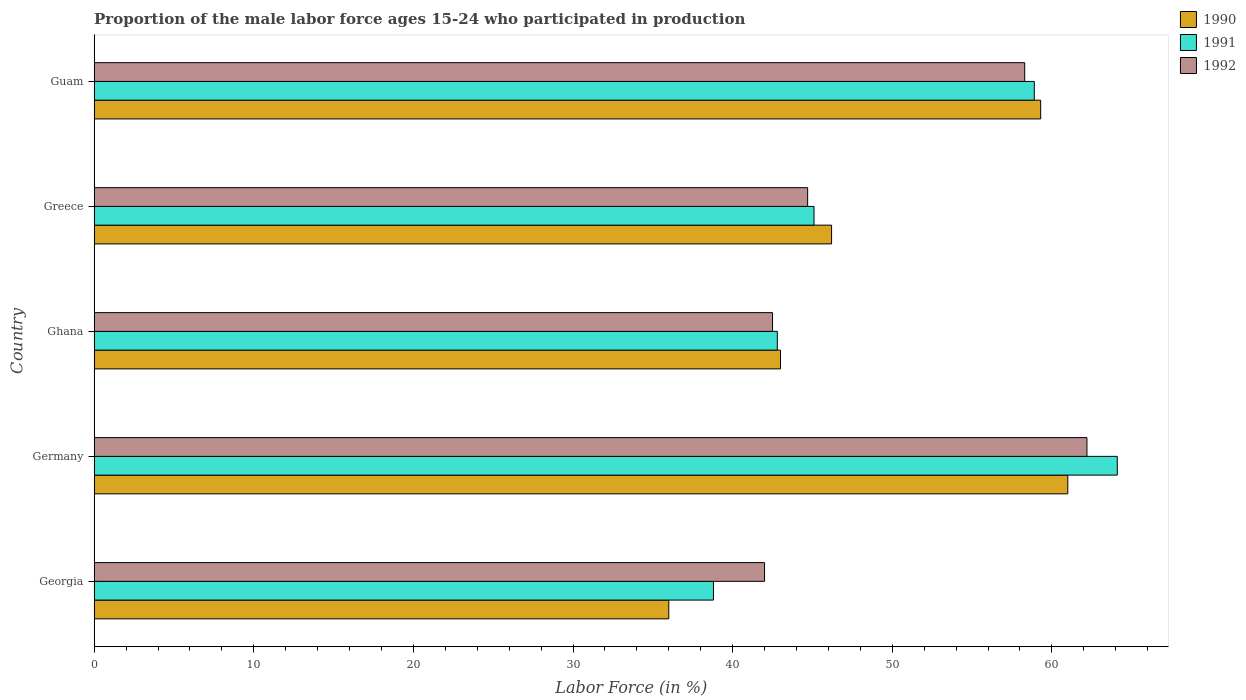How many different coloured bars are there?
Provide a short and direct response. 3. How many groups of bars are there?
Provide a succinct answer. 5. How many bars are there on the 2nd tick from the top?
Ensure brevity in your answer.  3. How many bars are there on the 1st tick from the bottom?
Keep it short and to the point. 3. What is the proportion of the male labor force who participated in production in 1990 in Ghana?
Offer a very short reply. 43. Across all countries, what is the maximum proportion of the male labor force who participated in production in 1992?
Keep it short and to the point. 62.2. Across all countries, what is the minimum proportion of the male labor force who participated in production in 1991?
Keep it short and to the point. 38.8. In which country was the proportion of the male labor force who participated in production in 1991 maximum?
Give a very brief answer. Germany. In which country was the proportion of the male labor force who participated in production in 1990 minimum?
Keep it short and to the point. Georgia. What is the total proportion of the male labor force who participated in production in 1990 in the graph?
Give a very brief answer. 245.5. What is the difference between the proportion of the male labor force who participated in production in 1991 in Georgia and that in Germany?
Ensure brevity in your answer.  -25.3. What is the difference between the proportion of the male labor force who participated in production in 1991 in Greece and the proportion of the male labor force who participated in production in 1990 in Georgia?
Offer a terse response. 9.1. What is the average proportion of the male labor force who participated in production in 1991 per country?
Provide a succinct answer. 49.94. What is the difference between the proportion of the male labor force who participated in production in 1991 and proportion of the male labor force who participated in production in 1990 in Ghana?
Give a very brief answer. -0.2. What is the ratio of the proportion of the male labor force who participated in production in 1991 in Georgia to that in Ghana?
Provide a succinct answer. 0.91. Is the proportion of the male labor force who participated in production in 1991 in Georgia less than that in Greece?
Provide a short and direct response. Yes. What is the difference between the highest and the second highest proportion of the male labor force who participated in production in 1990?
Offer a terse response. 1.7. What does the 3rd bar from the top in Greece represents?
Your answer should be very brief. 1990. What does the 1st bar from the bottom in Ghana represents?
Keep it short and to the point. 1990. Is it the case that in every country, the sum of the proportion of the male labor force who participated in production in 1991 and proportion of the male labor force who participated in production in 1992 is greater than the proportion of the male labor force who participated in production in 1990?
Your response must be concise. Yes. Are all the bars in the graph horizontal?
Your response must be concise. Yes. What is the difference between two consecutive major ticks on the X-axis?
Keep it short and to the point. 10. How are the legend labels stacked?
Keep it short and to the point. Vertical. What is the title of the graph?
Your answer should be compact. Proportion of the male labor force ages 15-24 who participated in production. Does "1992" appear as one of the legend labels in the graph?
Provide a succinct answer. Yes. What is the Labor Force (in %) in 1990 in Georgia?
Make the answer very short. 36. What is the Labor Force (in %) of 1991 in Georgia?
Ensure brevity in your answer.  38.8. What is the Labor Force (in %) in 1992 in Georgia?
Provide a succinct answer. 42. What is the Labor Force (in %) in 1991 in Germany?
Your answer should be compact. 64.1. What is the Labor Force (in %) of 1992 in Germany?
Your answer should be compact. 62.2. What is the Labor Force (in %) in 1991 in Ghana?
Provide a short and direct response. 42.8. What is the Labor Force (in %) in 1992 in Ghana?
Keep it short and to the point. 42.5. What is the Labor Force (in %) of 1990 in Greece?
Provide a succinct answer. 46.2. What is the Labor Force (in %) in 1991 in Greece?
Provide a succinct answer. 45.1. What is the Labor Force (in %) of 1992 in Greece?
Provide a short and direct response. 44.7. What is the Labor Force (in %) in 1990 in Guam?
Provide a succinct answer. 59.3. What is the Labor Force (in %) of 1991 in Guam?
Keep it short and to the point. 58.9. What is the Labor Force (in %) of 1992 in Guam?
Make the answer very short. 58.3. Across all countries, what is the maximum Labor Force (in %) in 1990?
Give a very brief answer. 61. Across all countries, what is the maximum Labor Force (in %) in 1991?
Provide a short and direct response. 64.1. Across all countries, what is the maximum Labor Force (in %) of 1992?
Keep it short and to the point. 62.2. Across all countries, what is the minimum Labor Force (in %) of 1990?
Give a very brief answer. 36. Across all countries, what is the minimum Labor Force (in %) in 1991?
Make the answer very short. 38.8. Across all countries, what is the minimum Labor Force (in %) of 1992?
Your response must be concise. 42. What is the total Labor Force (in %) of 1990 in the graph?
Your answer should be compact. 245.5. What is the total Labor Force (in %) in 1991 in the graph?
Your answer should be very brief. 249.7. What is the total Labor Force (in %) in 1992 in the graph?
Keep it short and to the point. 249.7. What is the difference between the Labor Force (in %) in 1990 in Georgia and that in Germany?
Provide a succinct answer. -25. What is the difference between the Labor Force (in %) of 1991 in Georgia and that in Germany?
Your response must be concise. -25.3. What is the difference between the Labor Force (in %) in 1992 in Georgia and that in Germany?
Offer a very short reply. -20.2. What is the difference between the Labor Force (in %) of 1991 in Georgia and that in Ghana?
Provide a succinct answer. -4. What is the difference between the Labor Force (in %) of 1992 in Georgia and that in Ghana?
Your answer should be very brief. -0.5. What is the difference between the Labor Force (in %) of 1992 in Georgia and that in Greece?
Provide a short and direct response. -2.7. What is the difference between the Labor Force (in %) in 1990 in Georgia and that in Guam?
Give a very brief answer. -23.3. What is the difference between the Labor Force (in %) in 1991 in Georgia and that in Guam?
Provide a succinct answer. -20.1. What is the difference between the Labor Force (in %) in 1992 in Georgia and that in Guam?
Your response must be concise. -16.3. What is the difference between the Labor Force (in %) of 1991 in Germany and that in Ghana?
Offer a terse response. 21.3. What is the difference between the Labor Force (in %) in 1992 in Germany and that in Greece?
Provide a succinct answer. 17.5. What is the difference between the Labor Force (in %) of 1990 in Germany and that in Guam?
Offer a very short reply. 1.7. What is the difference between the Labor Force (in %) of 1991 in Germany and that in Guam?
Your response must be concise. 5.2. What is the difference between the Labor Force (in %) in 1991 in Ghana and that in Greece?
Your answer should be compact. -2.3. What is the difference between the Labor Force (in %) of 1992 in Ghana and that in Greece?
Your answer should be compact. -2.2. What is the difference between the Labor Force (in %) in 1990 in Ghana and that in Guam?
Provide a succinct answer. -16.3. What is the difference between the Labor Force (in %) of 1991 in Ghana and that in Guam?
Make the answer very short. -16.1. What is the difference between the Labor Force (in %) in 1992 in Ghana and that in Guam?
Keep it short and to the point. -15.8. What is the difference between the Labor Force (in %) of 1991 in Greece and that in Guam?
Keep it short and to the point. -13.8. What is the difference between the Labor Force (in %) of 1990 in Georgia and the Labor Force (in %) of 1991 in Germany?
Your answer should be compact. -28.1. What is the difference between the Labor Force (in %) in 1990 in Georgia and the Labor Force (in %) in 1992 in Germany?
Ensure brevity in your answer.  -26.2. What is the difference between the Labor Force (in %) in 1991 in Georgia and the Labor Force (in %) in 1992 in Germany?
Provide a short and direct response. -23.4. What is the difference between the Labor Force (in %) of 1990 in Georgia and the Labor Force (in %) of 1991 in Greece?
Provide a succinct answer. -9.1. What is the difference between the Labor Force (in %) of 1990 in Georgia and the Labor Force (in %) of 1992 in Greece?
Your response must be concise. -8.7. What is the difference between the Labor Force (in %) of 1990 in Georgia and the Labor Force (in %) of 1991 in Guam?
Ensure brevity in your answer.  -22.9. What is the difference between the Labor Force (in %) of 1990 in Georgia and the Labor Force (in %) of 1992 in Guam?
Make the answer very short. -22.3. What is the difference between the Labor Force (in %) in 1991 in Georgia and the Labor Force (in %) in 1992 in Guam?
Provide a succinct answer. -19.5. What is the difference between the Labor Force (in %) of 1991 in Germany and the Labor Force (in %) of 1992 in Ghana?
Provide a short and direct response. 21.6. What is the difference between the Labor Force (in %) of 1990 in Germany and the Labor Force (in %) of 1991 in Greece?
Give a very brief answer. 15.9. What is the difference between the Labor Force (in %) of 1990 in Germany and the Labor Force (in %) of 1992 in Greece?
Offer a terse response. 16.3. What is the difference between the Labor Force (in %) in 1990 in Germany and the Labor Force (in %) in 1991 in Guam?
Offer a very short reply. 2.1. What is the difference between the Labor Force (in %) of 1990 in Ghana and the Labor Force (in %) of 1991 in Greece?
Provide a succinct answer. -2.1. What is the difference between the Labor Force (in %) in 1991 in Ghana and the Labor Force (in %) in 1992 in Greece?
Provide a short and direct response. -1.9. What is the difference between the Labor Force (in %) of 1990 in Ghana and the Labor Force (in %) of 1991 in Guam?
Offer a very short reply. -15.9. What is the difference between the Labor Force (in %) of 1990 in Ghana and the Labor Force (in %) of 1992 in Guam?
Your answer should be compact. -15.3. What is the difference between the Labor Force (in %) of 1991 in Ghana and the Labor Force (in %) of 1992 in Guam?
Your response must be concise. -15.5. What is the difference between the Labor Force (in %) of 1990 in Greece and the Labor Force (in %) of 1991 in Guam?
Offer a terse response. -12.7. What is the average Labor Force (in %) in 1990 per country?
Provide a short and direct response. 49.1. What is the average Labor Force (in %) of 1991 per country?
Ensure brevity in your answer.  49.94. What is the average Labor Force (in %) of 1992 per country?
Provide a short and direct response. 49.94. What is the difference between the Labor Force (in %) in 1990 and Labor Force (in %) in 1991 in Georgia?
Provide a short and direct response. -2.8. What is the difference between the Labor Force (in %) in 1991 and Labor Force (in %) in 1992 in Georgia?
Ensure brevity in your answer.  -3.2. What is the difference between the Labor Force (in %) of 1990 and Labor Force (in %) of 1992 in Germany?
Your answer should be very brief. -1.2. What is the difference between the Labor Force (in %) of 1991 and Labor Force (in %) of 1992 in Germany?
Make the answer very short. 1.9. What is the difference between the Labor Force (in %) of 1990 and Labor Force (in %) of 1992 in Ghana?
Offer a very short reply. 0.5. What is the difference between the Labor Force (in %) of 1990 and Labor Force (in %) of 1991 in Greece?
Give a very brief answer. 1.1. What is the difference between the Labor Force (in %) in 1990 and Labor Force (in %) in 1992 in Greece?
Offer a terse response. 1.5. What is the difference between the Labor Force (in %) in 1991 and Labor Force (in %) in 1992 in Greece?
Offer a terse response. 0.4. What is the difference between the Labor Force (in %) in 1990 and Labor Force (in %) in 1992 in Guam?
Your answer should be very brief. 1. What is the difference between the Labor Force (in %) of 1991 and Labor Force (in %) of 1992 in Guam?
Provide a short and direct response. 0.6. What is the ratio of the Labor Force (in %) in 1990 in Georgia to that in Germany?
Keep it short and to the point. 0.59. What is the ratio of the Labor Force (in %) in 1991 in Georgia to that in Germany?
Make the answer very short. 0.61. What is the ratio of the Labor Force (in %) in 1992 in Georgia to that in Germany?
Offer a very short reply. 0.68. What is the ratio of the Labor Force (in %) in 1990 in Georgia to that in Ghana?
Offer a very short reply. 0.84. What is the ratio of the Labor Force (in %) of 1991 in Georgia to that in Ghana?
Offer a very short reply. 0.91. What is the ratio of the Labor Force (in %) of 1992 in Georgia to that in Ghana?
Ensure brevity in your answer.  0.99. What is the ratio of the Labor Force (in %) in 1990 in Georgia to that in Greece?
Offer a very short reply. 0.78. What is the ratio of the Labor Force (in %) of 1991 in Georgia to that in Greece?
Keep it short and to the point. 0.86. What is the ratio of the Labor Force (in %) of 1992 in Georgia to that in Greece?
Ensure brevity in your answer.  0.94. What is the ratio of the Labor Force (in %) of 1990 in Georgia to that in Guam?
Provide a short and direct response. 0.61. What is the ratio of the Labor Force (in %) of 1991 in Georgia to that in Guam?
Make the answer very short. 0.66. What is the ratio of the Labor Force (in %) of 1992 in Georgia to that in Guam?
Your answer should be very brief. 0.72. What is the ratio of the Labor Force (in %) in 1990 in Germany to that in Ghana?
Give a very brief answer. 1.42. What is the ratio of the Labor Force (in %) of 1991 in Germany to that in Ghana?
Keep it short and to the point. 1.5. What is the ratio of the Labor Force (in %) in 1992 in Germany to that in Ghana?
Offer a terse response. 1.46. What is the ratio of the Labor Force (in %) of 1990 in Germany to that in Greece?
Your answer should be compact. 1.32. What is the ratio of the Labor Force (in %) of 1991 in Germany to that in Greece?
Provide a succinct answer. 1.42. What is the ratio of the Labor Force (in %) in 1992 in Germany to that in Greece?
Your answer should be compact. 1.39. What is the ratio of the Labor Force (in %) in 1990 in Germany to that in Guam?
Provide a succinct answer. 1.03. What is the ratio of the Labor Force (in %) of 1991 in Germany to that in Guam?
Provide a succinct answer. 1.09. What is the ratio of the Labor Force (in %) in 1992 in Germany to that in Guam?
Keep it short and to the point. 1.07. What is the ratio of the Labor Force (in %) in 1990 in Ghana to that in Greece?
Your response must be concise. 0.93. What is the ratio of the Labor Force (in %) in 1991 in Ghana to that in Greece?
Your answer should be compact. 0.95. What is the ratio of the Labor Force (in %) of 1992 in Ghana to that in Greece?
Your answer should be very brief. 0.95. What is the ratio of the Labor Force (in %) in 1990 in Ghana to that in Guam?
Keep it short and to the point. 0.73. What is the ratio of the Labor Force (in %) in 1991 in Ghana to that in Guam?
Your answer should be compact. 0.73. What is the ratio of the Labor Force (in %) of 1992 in Ghana to that in Guam?
Offer a terse response. 0.73. What is the ratio of the Labor Force (in %) of 1990 in Greece to that in Guam?
Your answer should be compact. 0.78. What is the ratio of the Labor Force (in %) in 1991 in Greece to that in Guam?
Your answer should be very brief. 0.77. What is the ratio of the Labor Force (in %) of 1992 in Greece to that in Guam?
Ensure brevity in your answer.  0.77. What is the difference between the highest and the second highest Labor Force (in %) in 1990?
Your answer should be compact. 1.7. What is the difference between the highest and the second highest Labor Force (in %) in 1992?
Your response must be concise. 3.9. What is the difference between the highest and the lowest Labor Force (in %) of 1990?
Ensure brevity in your answer.  25. What is the difference between the highest and the lowest Labor Force (in %) in 1991?
Make the answer very short. 25.3. What is the difference between the highest and the lowest Labor Force (in %) of 1992?
Provide a short and direct response. 20.2. 